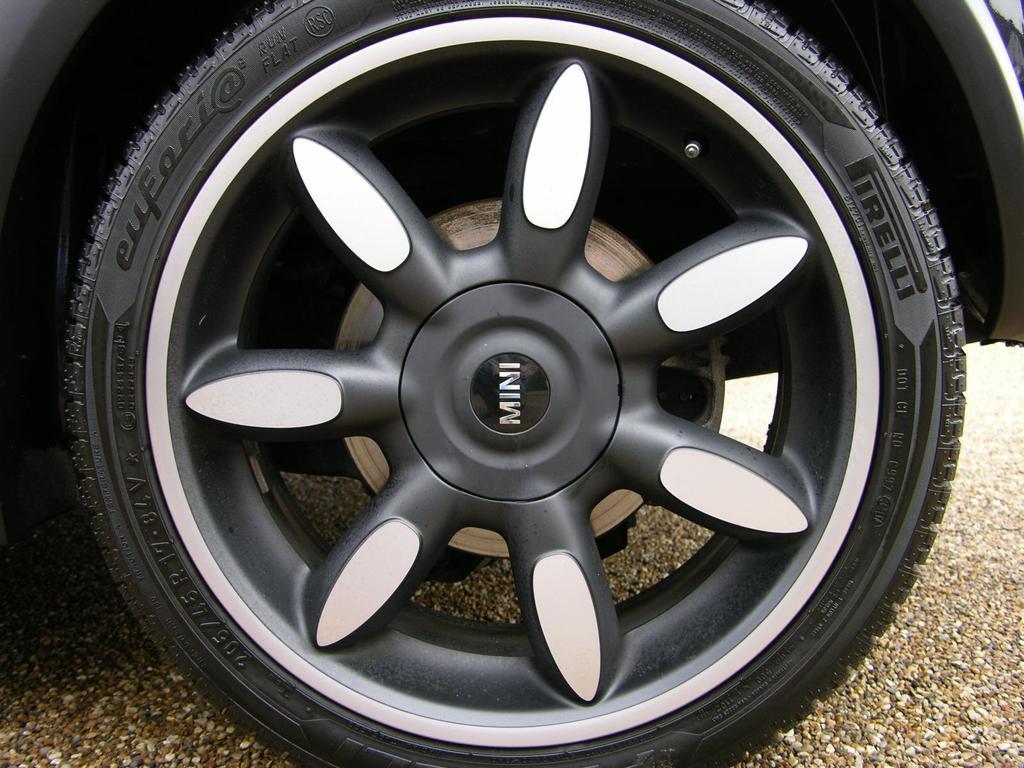How would you summarize this image in a sentence or two? In this image I can see a wheel of a vehicle which is black and white in color. I can see the ground which is brown in color. 